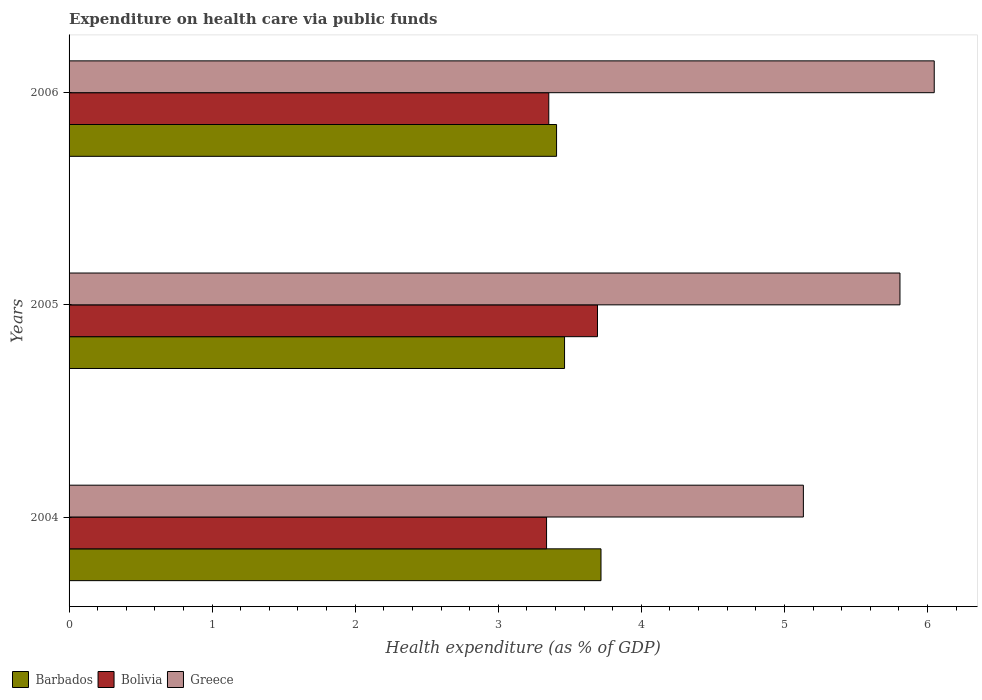How many groups of bars are there?
Provide a short and direct response. 3. Are the number of bars per tick equal to the number of legend labels?
Your answer should be very brief. Yes. Are the number of bars on each tick of the Y-axis equal?
Your answer should be compact. Yes. What is the label of the 1st group of bars from the top?
Your answer should be compact. 2006. In how many cases, is the number of bars for a given year not equal to the number of legend labels?
Your response must be concise. 0. What is the expenditure made on health care in Bolivia in 2006?
Your answer should be compact. 3.35. Across all years, what is the maximum expenditure made on health care in Barbados?
Provide a short and direct response. 3.72. Across all years, what is the minimum expenditure made on health care in Greece?
Give a very brief answer. 5.13. What is the total expenditure made on health care in Greece in the graph?
Your answer should be compact. 16.99. What is the difference between the expenditure made on health care in Bolivia in 2005 and that in 2006?
Provide a short and direct response. 0.34. What is the difference between the expenditure made on health care in Barbados in 2004 and the expenditure made on health care in Bolivia in 2006?
Your answer should be compact. 0.36. What is the average expenditure made on health care in Barbados per year?
Your response must be concise. 3.53. In the year 2006, what is the difference between the expenditure made on health care in Greece and expenditure made on health care in Barbados?
Provide a succinct answer. 2.64. In how many years, is the expenditure made on health care in Barbados greater than 1.6 %?
Provide a succinct answer. 3. What is the ratio of the expenditure made on health care in Barbados in 2004 to that in 2006?
Provide a succinct answer. 1.09. Is the expenditure made on health care in Bolivia in 2005 less than that in 2006?
Give a very brief answer. No. Is the difference between the expenditure made on health care in Greece in 2004 and 2005 greater than the difference between the expenditure made on health care in Barbados in 2004 and 2005?
Give a very brief answer. No. What is the difference between the highest and the second highest expenditure made on health care in Barbados?
Offer a very short reply. 0.25. What is the difference between the highest and the lowest expenditure made on health care in Bolivia?
Ensure brevity in your answer.  0.36. In how many years, is the expenditure made on health care in Bolivia greater than the average expenditure made on health care in Bolivia taken over all years?
Offer a terse response. 1. Is the sum of the expenditure made on health care in Greece in 2005 and 2006 greater than the maximum expenditure made on health care in Barbados across all years?
Ensure brevity in your answer.  Yes. Is it the case that in every year, the sum of the expenditure made on health care in Greece and expenditure made on health care in Bolivia is greater than the expenditure made on health care in Barbados?
Give a very brief answer. Yes. How many years are there in the graph?
Provide a short and direct response. 3. What is the difference between two consecutive major ticks on the X-axis?
Offer a very short reply. 1. Are the values on the major ticks of X-axis written in scientific E-notation?
Ensure brevity in your answer.  No. What is the title of the graph?
Your answer should be very brief. Expenditure on health care via public funds. What is the label or title of the X-axis?
Your response must be concise. Health expenditure (as % of GDP). What is the Health expenditure (as % of GDP) in Barbados in 2004?
Make the answer very short. 3.72. What is the Health expenditure (as % of GDP) in Bolivia in 2004?
Give a very brief answer. 3.34. What is the Health expenditure (as % of GDP) of Greece in 2004?
Keep it short and to the point. 5.13. What is the Health expenditure (as % of GDP) in Barbados in 2005?
Ensure brevity in your answer.  3.46. What is the Health expenditure (as % of GDP) in Bolivia in 2005?
Make the answer very short. 3.69. What is the Health expenditure (as % of GDP) of Greece in 2005?
Give a very brief answer. 5.81. What is the Health expenditure (as % of GDP) of Barbados in 2006?
Ensure brevity in your answer.  3.41. What is the Health expenditure (as % of GDP) in Bolivia in 2006?
Your answer should be compact. 3.35. What is the Health expenditure (as % of GDP) of Greece in 2006?
Provide a succinct answer. 6.05. Across all years, what is the maximum Health expenditure (as % of GDP) in Barbados?
Your answer should be very brief. 3.72. Across all years, what is the maximum Health expenditure (as % of GDP) in Bolivia?
Your answer should be very brief. 3.69. Across all years, what is the maximum Health expenditure (as % of GDP) in Greece?
Offer a very short reply. 6.05. Across all years, what is the minimum Health expenditure (as % of GDP) in Barbados?
Provide a short and direct response. 3.41. Across all years, what is the minimum Health expenditure (as % of GDP) of Bolivia?
Keep it short and to the point. 3.34. Across all years, what is the minimum Health expenditure (as % of GDP) in Greece?
Your answer should be very brief. 5.13. What is the total Health expenditure (as % of GDP) of Barbados in the graph?
Offer a terse response. 10.59. What is the total Health expenditure (as % of GDP) of Bolivia in the graph?
Make the answer very short. 10.38. What is the total Health expenditure (as % of GDP) in Greece in the graph?
Your response must be concise. 16.99. What is the difference between the Health expenditure (as % of GDP) of Barbados in 2004 and that in 2005?
Your answer should be very brief. 0.25. What is the difference between the Health expenditure (as % of GDP) of Bolivia in 2004 and that in 2005?
Offer a terse response. -0.36. What is the difference between the Health expenditure (as % of GDP) in Greece in 2004 and that in 2005?
Provide a short and direct response. -0.68. What is the difference between the Health expenditure (as % of GDP) in Barbados in 2004 and that in 2006?
Offer a very short reply. 0.31. What is the difference between the Health expenditure (as % of GDP) in Bolivia in 2004 and that in 2006?
Offer a very short reply. -0.02. What is the difference between the Health expenditure (as % of GDP) in Greece in 2004 and that in 2006?
Your response must be concise. -0.91. What is the difference between the Health expenditure (as % of GDP) of Barbados in 2005 and that in 2006?
Your response must be concise. 0.06. What is the difference between the Health expenditure (as % of GDP) of Bolivia in 2005 and that in 2006?
Offer a terse response. 0.34. What is the difference between the Health expenditure (as % of GDP) in Greece in 2005 and that in 2006?
Keep it short and to the point. -0.24. What is the difference between the Health expenditure (as % of GDP) in Barbados in 2004 and the Health expenditure (as % of GDP) in Bolivia in 2005?
Give a very brief answer. 0.02. What is the difference between the Health expenditure (as % of GDP) of Barbados in 2004 and the Health expenditure (as % of GDP) of Greece in 2005?
Offer a terse response. -2.09. What is the difference between the Health expenditure (as % of GDP) in Bolivia in 2004 and the Health expenditure (as % of GDP) in Greece in 2005?
Your answer should be compact. -2.47. What is the difference between the Health expenditure (as % of GDP) in Barbados in 2004 and the Health expenditure (as % of GDP) in Bolivia in 2006?
Make the answer very short. 0.36. What is the difference between the Health expenditure (as % of GDP) in Barbados in 2004 and the Health expenditure (as % of GDP) in Greece in 2006?
Make the answer very short. -2.33. What is the difference between the Health expenditure (as % of GDP) of Bolivia in 2004 and the Health expenditure (as % of GDP) of Greece in 2006?
Your response must be concise. -2.71. What is the difference between the Health expenditure (as % of GDP) in Barbados in 2005 and the Health expenditure (as % of GDP) in Bolivia in 2006?
Provide a short and direct response. 0.11. What is the difference between the Health expenditure (as % of GDP) of Barbados in 2005 and the Health expenditure (as % of GDP) of Greece in 2006?
Ensure brevity in your answer.  -2.58. What is the difference between the Health expenditure (as % of GDP) of Bolivia in 2005 and the Health expenditure (as % of GDP) of Greece in 2006?
Provide a succinct answer. -2.35. What is the average Health expenditure (as % of GDP) of Barbados per year?
Your response must be concise. 3.53. What is the average Health expenditure (as % of GDP) in Bolivia per year?
Offer a very short reply. 3.46. What is the average Health expenditure (as % of GDP) in Greece per year?
Your answer should be compact. 5.66. In the year 2004, what is the difference between the Health expenditure (as % of GDP) in Barbados and Health expenditure (as % of GDP) in Bolivia?
Your answer should be very brief. 0.38. In the year 2004, what is the difference between the Health expenditure (as % of GDP) in Barbados and Health expenditure (as % of GDP) in Greece?
Ensure brevity in your answer.  -1.41. In the year 2004, what is the difference between the Health expenditure (as % of GDP) of Bolivia and Health expenditure (as % of GDP) of Greece?
Make the answer very short. -1.8. In the year 2005, what is the difference between the Health expenditure (as % of GDP) of Barbados and Health expenditure (as % of GDP) of Bolivia?
Provide a succinct answer. -0.23. In the year 2005, what is the difference between the Health expenditure (as % of GDP) of Barbados and Health expenditure (as % of GDP) of Greece?
Offer a very short reply. -2.34. In the year 2005, what is the difference between the Health expenditure (as % of GDP) of Bolivia and Health expenditure (as % of GDP) of Greece?
Provide a succinct answer. -2.11. In the year 2006, what is the difference between the Health expenditure (as % of GDP) of Barbados and Health expenditure (as % of GDP) of Bolivia?
Make the answer very short. 0.05. In the year 2006, what is the difference between the Health expenditure (as % of GDP) of Barbados and Health expenditure (as % of GDP) of Greece?
Provide a succinct answer. -2.64. In the year 2006, what is the difference between the Health expenditure (as % of GDP) in Bolivia and Health expenditure (as % of GDP) in Greece?
Ensure brevity in your answer.  -2.69. What is the ratio of the Health expenditure (as % of GDP) in Barbados in 2004 to that in 2005?
Provide a succinct answer. 1.07. What is the ratio of the Health expenditure (as % of GDP) in Bolivia in 2004 to that in 2005?
Provide a succinct answer. 0.9. What is the ratio of the Health expenditure (as % of GDP) in Greece in 2004 to that in 2005?
Ensure brevity in your answer.  0.88. What is the ratio of the Health expenditure (as % of GDP) of Barbados in 2004 to that in 2006?
Provide a succinct answer. 1.09. What is the ratio of the Health expenditure (as % of GDP) in Greece in 2004 to that in 2006?
Give a very brief answer. 0.85. What is the ratio of the Health expenditure (as % of GDP) in Barbados in 2005 to that in 2006?
Provide a short and direct response. 1.02. What is the ratio of the Health expenditure (as % of GDP) in Bolivia in 2005 to that in 2006?
Provide a short and direct response. 1.1. What is the ratio of the Health expenditure (as % of GDP) of Greece in 2005 to that in 2006?
Offer a terse response. 0.96. What is the difference between the highest and the second highest Health expenditure (as % of GDP) of Barbados?
Your response must be concise. 0.25. What is the difference between the highest and the second highest Health expenditure (as % of GDP) of Bolivia?
Provide a short and direct response. 0.34. What is the difference between the highest and the second highest Health expenditure (as % of GDP) in Greece?
Offer a terse response. 0.24. What is the difference between the highest and the lowest Health expenditure (as % of GDP) in Barbados?
Provide a short and direct response. 0.31. What is the difference between the highest and the lowest Health expenditure (as % of GDP) of Bolivia?
Offer a terse response. 0.36. What is the difference between the highest and the lowest Health expenditure (as % of GDP) of Greece?
Provide a succinct answer. 0.91. 